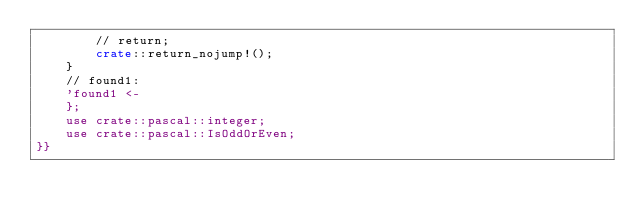Convert code to text. <code><loc_0><loc_0><loc_500><loc_500><_Rust_>        // return;
        crate::return_nojump!();
    }
    // found1:
    'found1 <-
    };
    use crate::pascal::integer;
    use crate::pascal::IsOddOrEven;
}}
</code> 